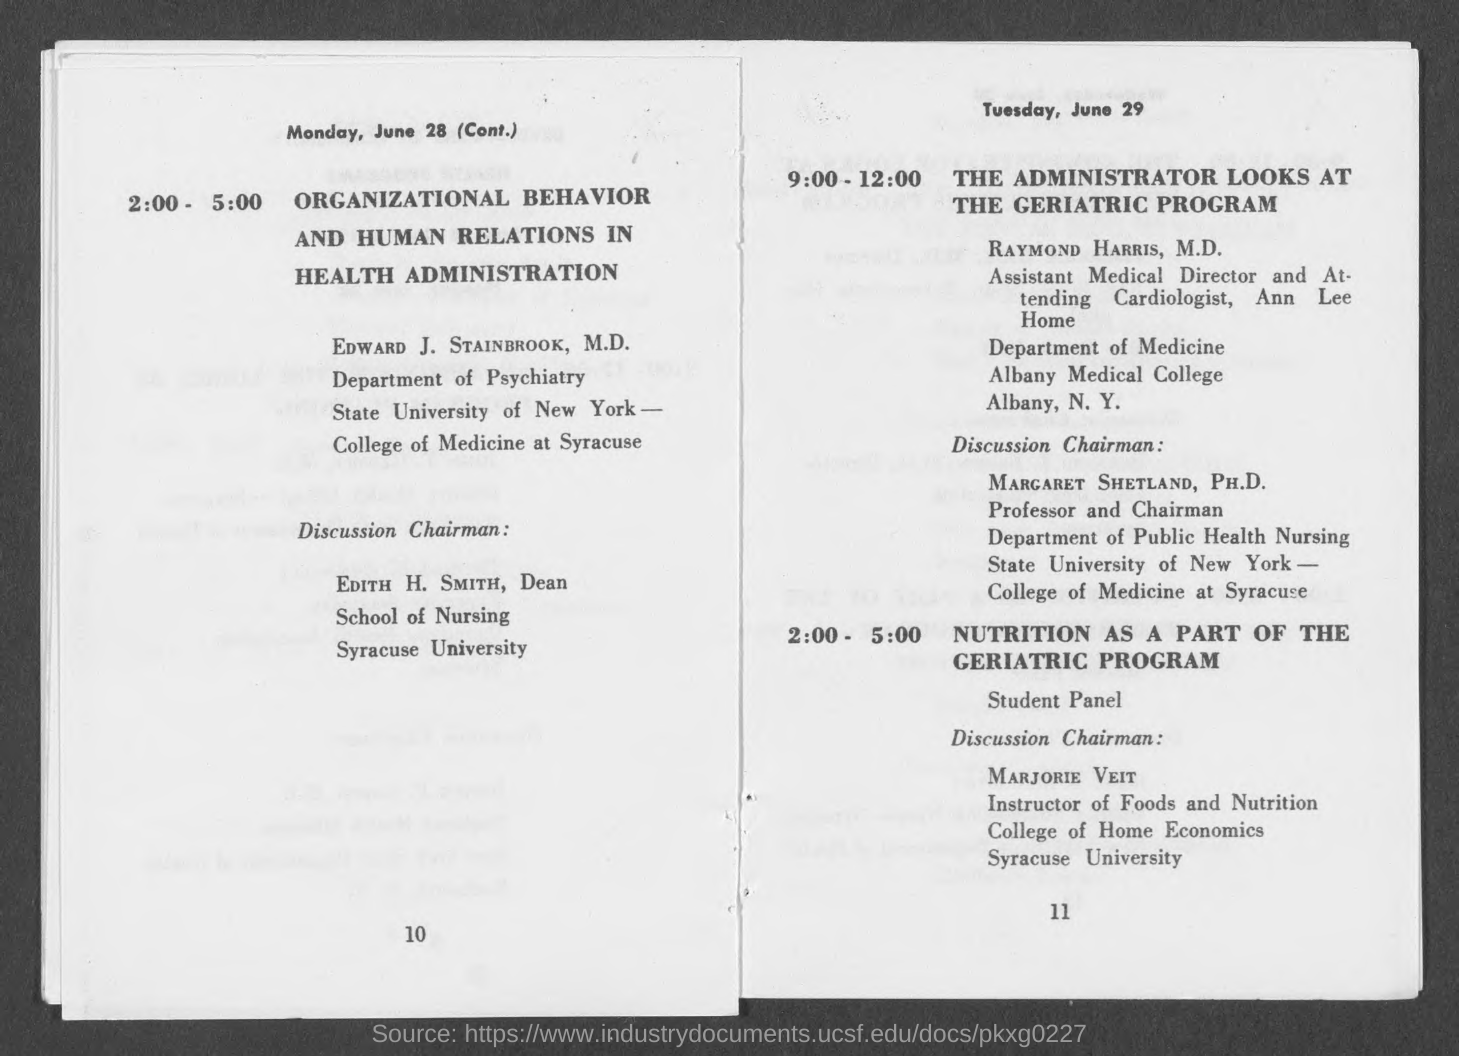Highlight a few significant elements in this photo. The instructor of Foods and Nutrition is Marjorie Veit. On June 29 from 9:00-12:00, Raymond Harris is in charge of the program. It is Edith H. Smith who will be serving as the Discussion Chairman from 2:00 - 5:00 on June 28. From 2:00 - 5:00, the program is devoted to the study of organizational behavior and human relations in health administration. 